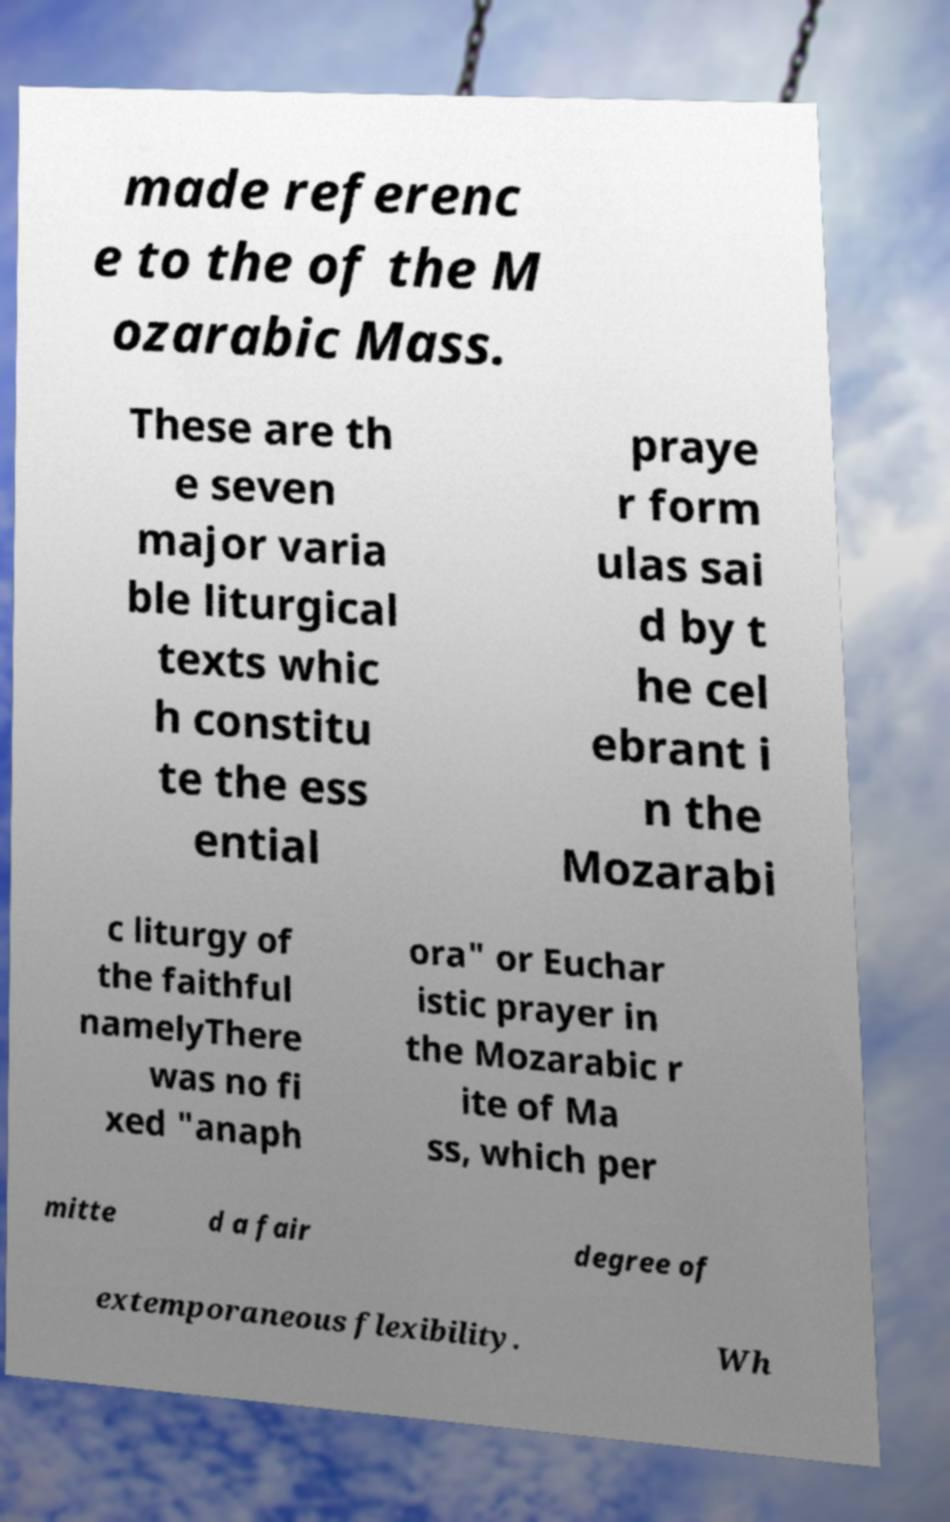Please read and relay the text visible in this image. What does it say? made referenc e to the of the M ozarabic Mass. These are th e seven major varia ble liturgical texts whic h constitu te the ess ential praye r form ulas sai d by t he cel ebrant i n the Mozarabi c liturgy of the faithful namelyThere was no fi xed "anaph ora" or Euchar istic prayer in the Mozarabic r ite of Ma ss, which per mitte d a fair degree of extemporaneous flexibility. Wh 